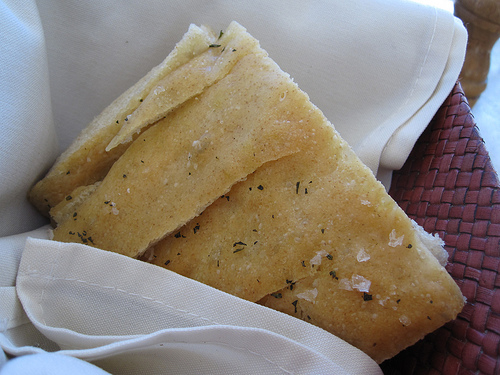<image>
Is the food on the cotton? Yes. Looking at the image, I can see the food is positioned on top of the cotton, with the cotton providing support. 